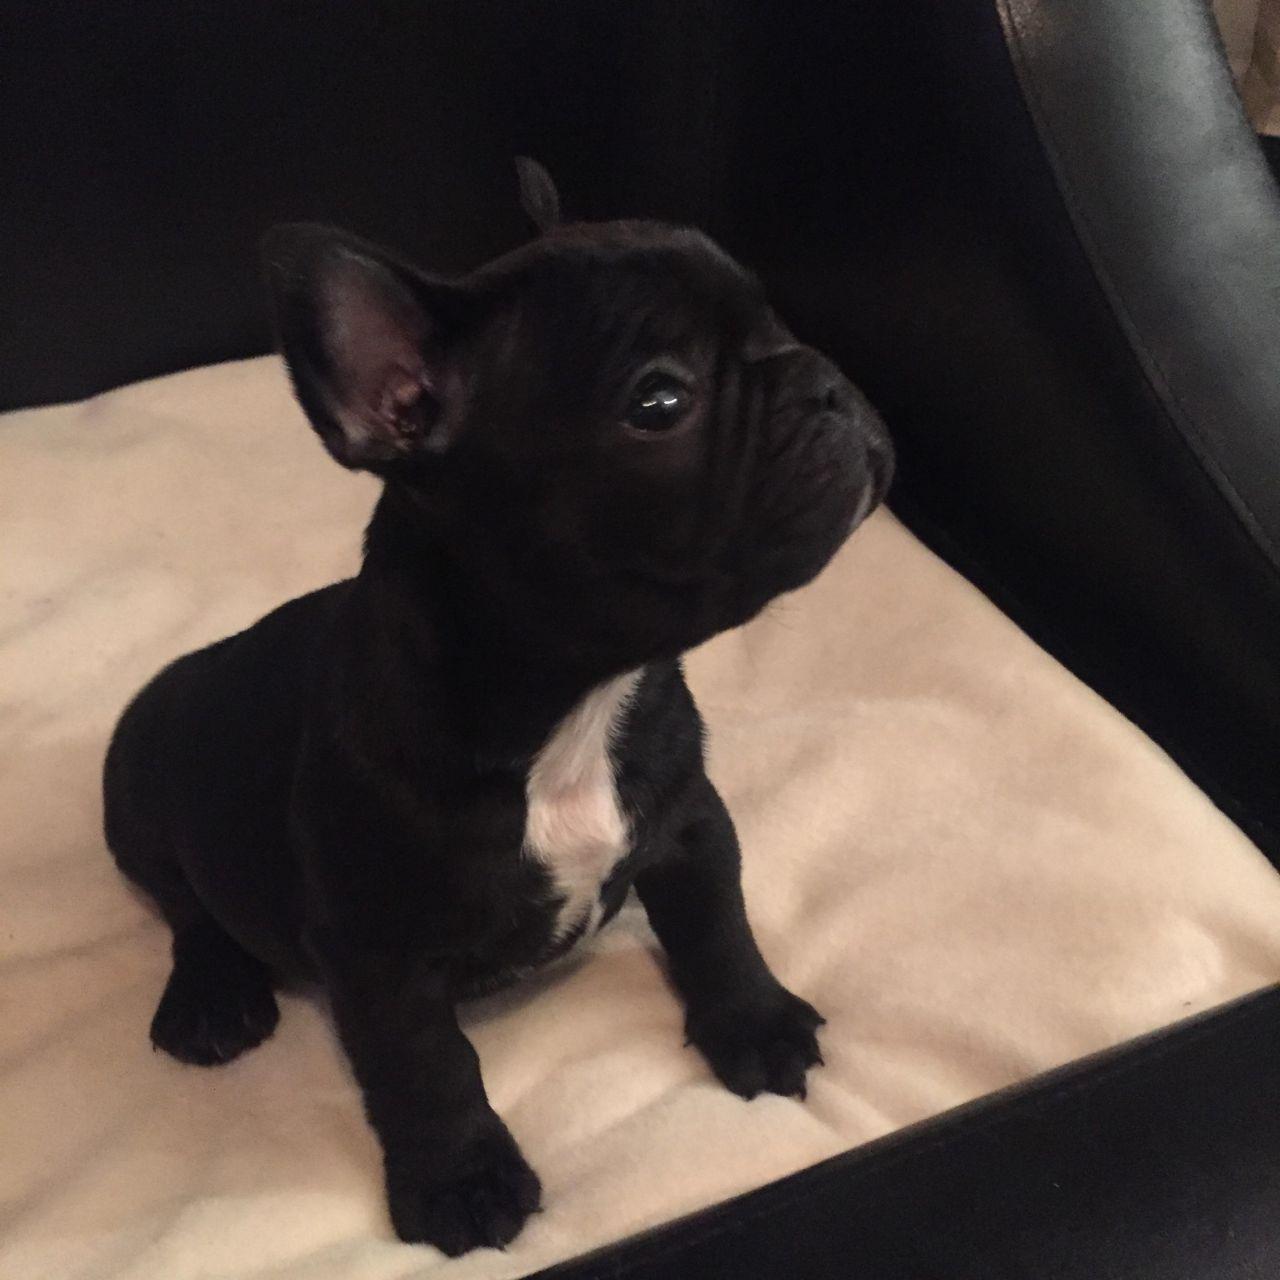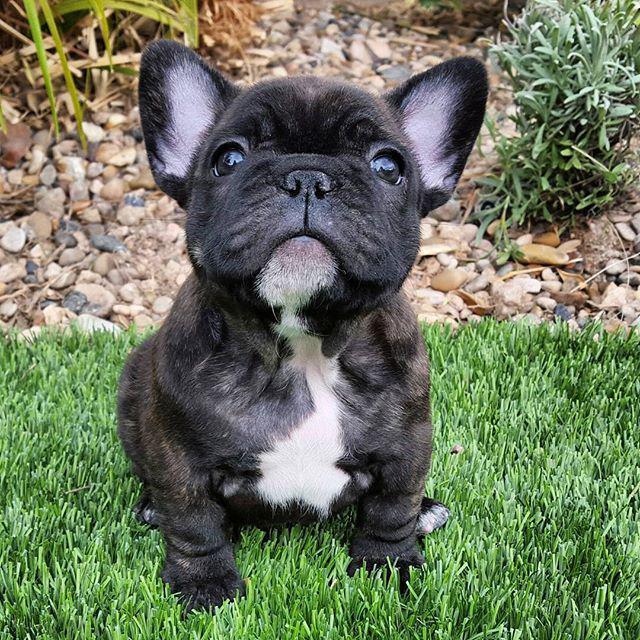The first image is the image on the left, the second image is the image on the right. Evaluate the accuracy of this statement regarding the images: "A single French Bulldog is standing up in the grass.". Is it true? Answer yes or no. No. 